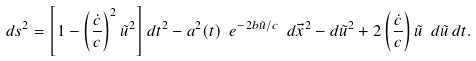<formula> <loc_0><loc_0><loc_500><loc_500>d s ^ { 2 } = \left [ 1 - \left ( \frac { \dot { c } } { c } \right ) ^ { 2 } \tilde { u } ^ { 2 } \right ] d t ^ { 2 } - a ^ { 2 } ( t ) \ e ^ { - 2 b \tilde { u } / c } \ d \vec { x } ^ { 2 } - d \tilde { u } ^ { 2 } + 2 \left ( \frac { \dot { c } } { c } \right ) \tilde { u } \ d \tilde { u } \, d t .</formula> 